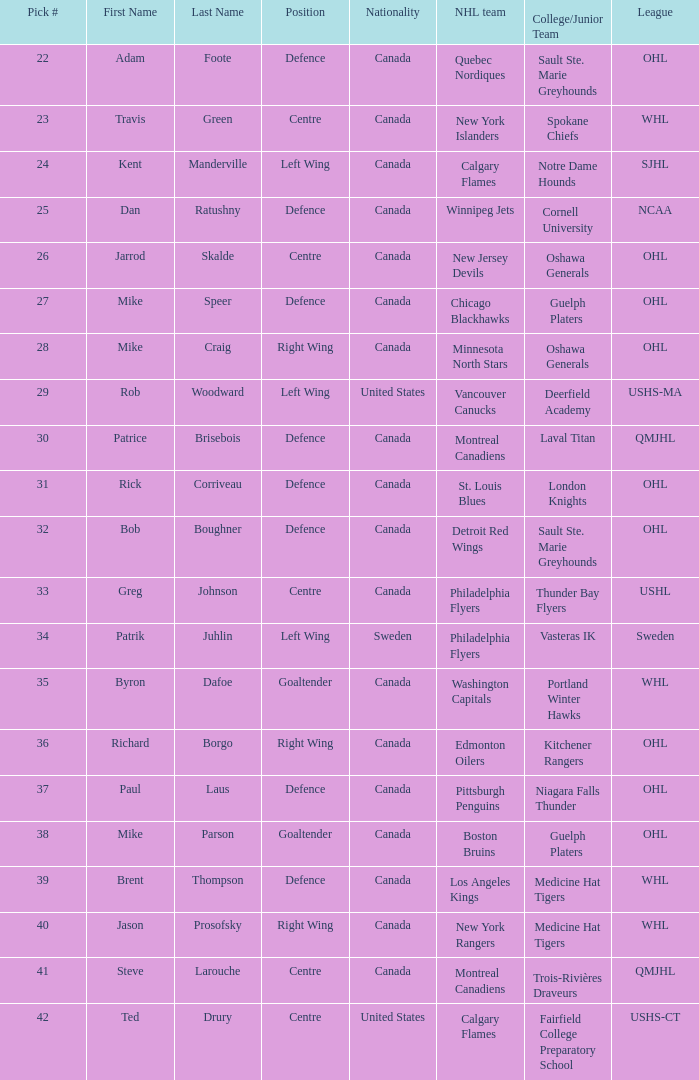What player came from Cornell University (NCAA)? Dan Ratushny. 